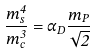Convert formula to latex. <formula><loc_0><loc_0><loc_500><loc_500>\frac { m _ { s } ^ { 4 } } { m _ { c } ^ { 3 } } = \alpha _ { D } \frac { m _ { P } } { \sqrt { 2 } }</formula> 